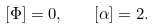Convert formula to latex. <formula><loc_0><loc_0><loc_500><loc_500>[ \Phi ] = 0 , \quad [ \alpha ] = 2 .</formula> 